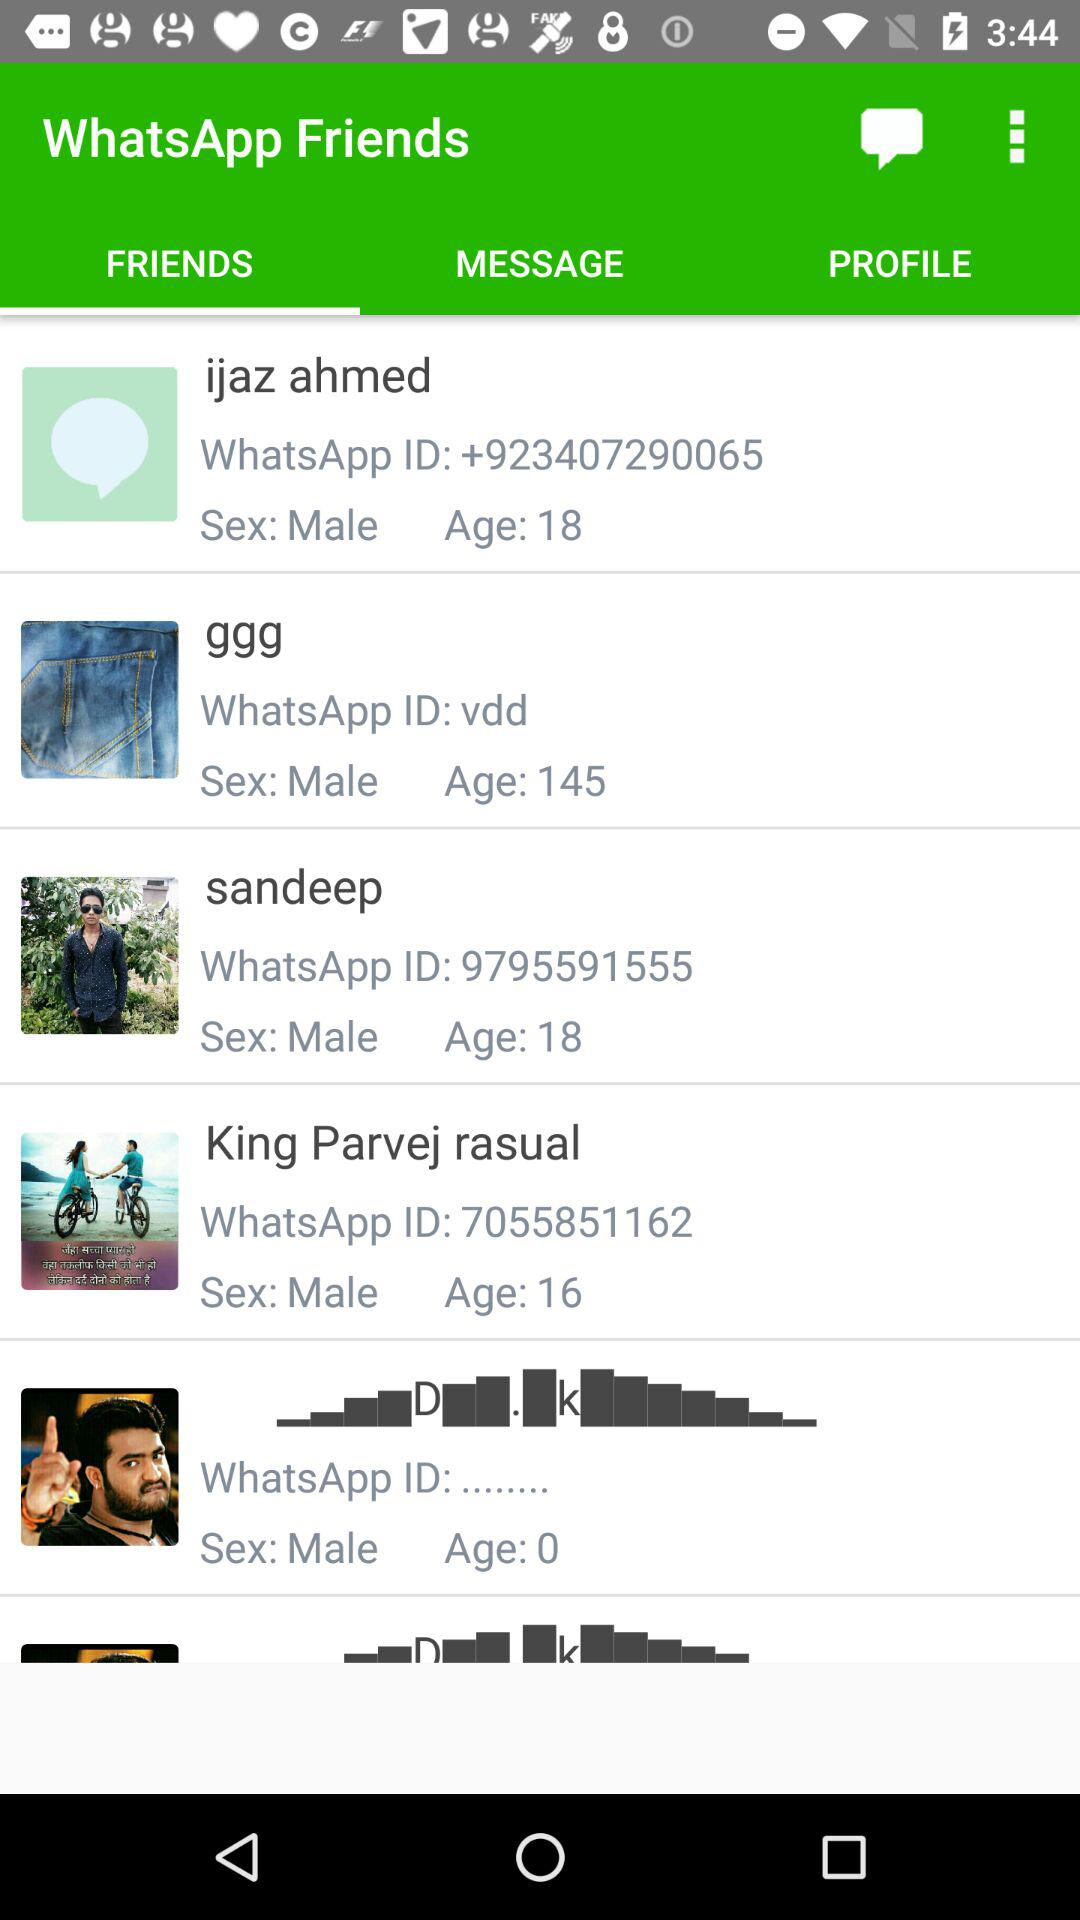What is the age of Sandeep? The age of Sandeep is 18. 